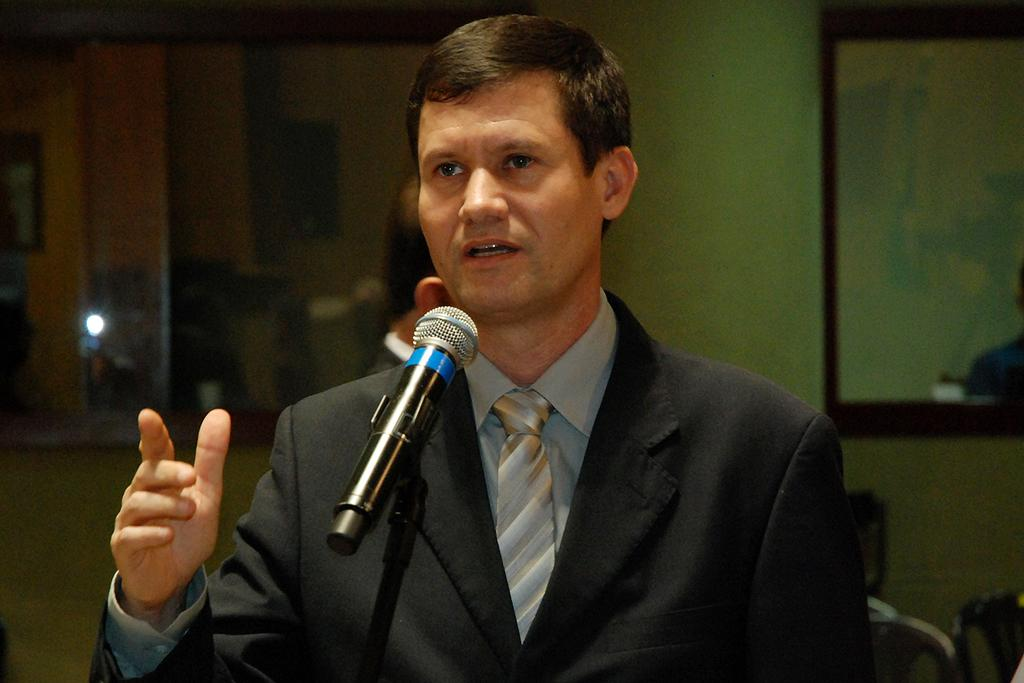What object in the image allows for reflection? There is a mirror in the image. What type of structure can be seen in the image? There is a wall in the image. What is the man in the image wearing? The man in the image is wearing a black jacket. What device is present for amplifying sound? There is a mic in the image. How would you describe the lighting in the image? The background of the image is dark. Where is the hydrant located in the image? There is no hydrant present in the image. What type of plant can be seen growing near the wall in the image? There is no plant visible in the image. 